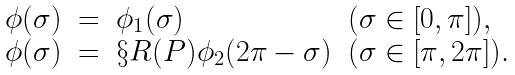<formula> <loc_0><loc_0><loc_500><loc_500>\begin{array} { r c l l } \phi ( \sigma ) & = & \phi _ { 1 } ( \sigma ) & ( \sigma \in [ 0 , \pi ] ) , \\ \phi ( \sigma ) & = & \S R ( P ) \phi _ { 2 } ( 2 \pi - \sigma ) & ( \sigma \in [ \pi , 2 \pi ] ) . \end{array}</formula> 